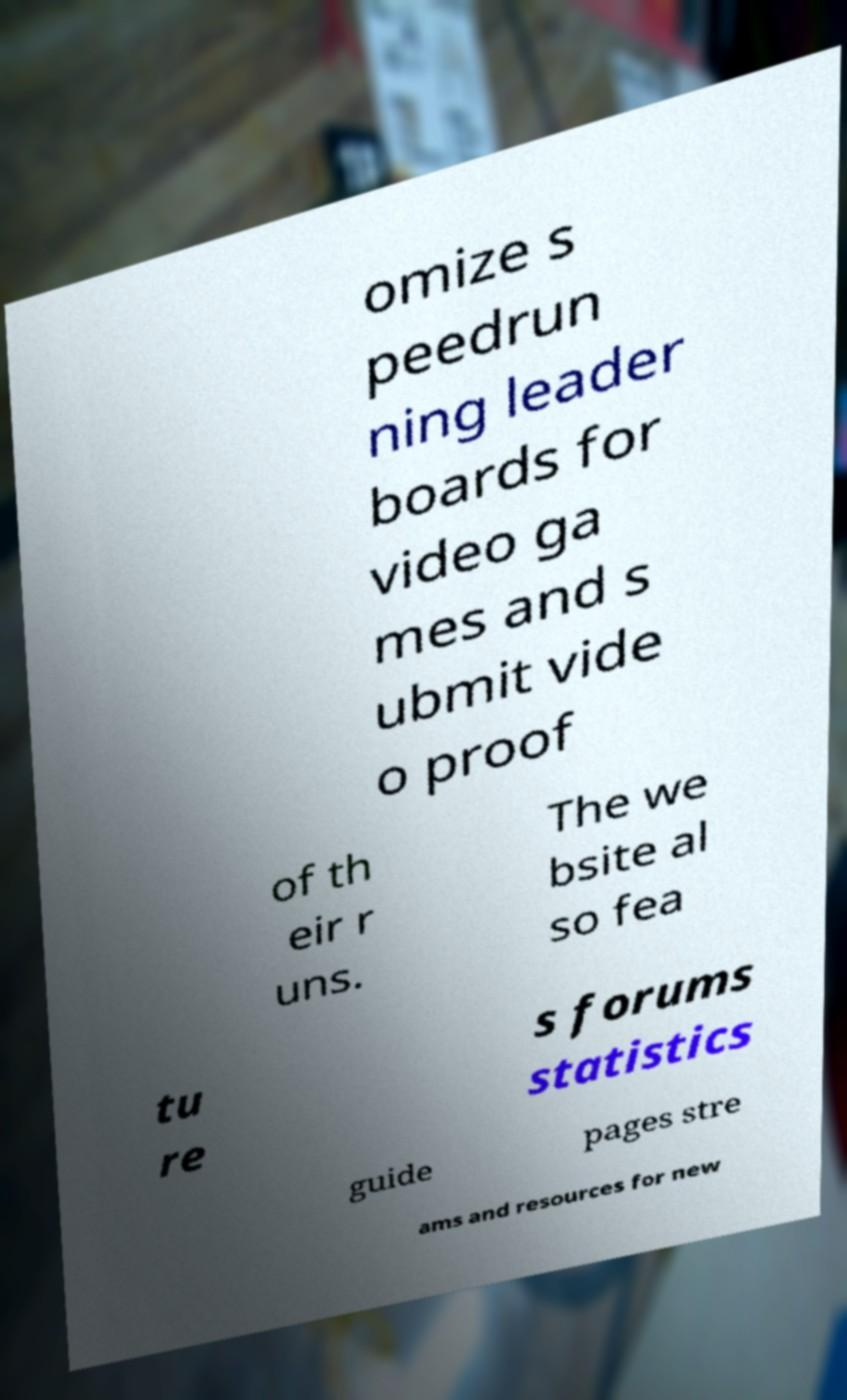For documentation purposes, I need the text within this image transcribed. Could you provide that? omize s peedrun ning leader boards for video ga mes and s ubmit vide o proof of th eir r uns. The we bsite al so fea tu re s forums statistics guide pages stre ams and resources for new 